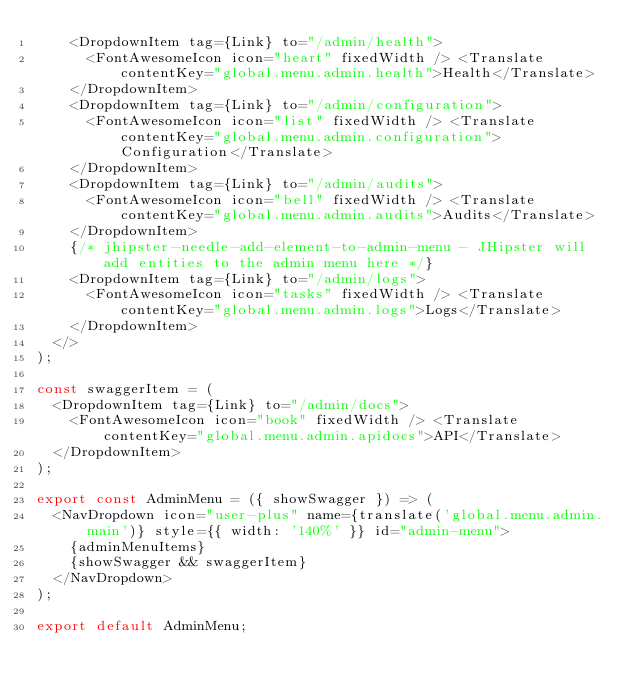Convert code to text. <code><loc_0><loc_0><loc_500><loc_500><_TypeScript_>    <DropdownItem tag={Link} to="/admin/health">
      <FontAwesomeIcon icon="heart" fixedWidth /> <Translate contentKey="global.menu.admin.health">Health</Translate>
    </DropdownItem>
    <DropdownItem tag={Link} to="/admin/configuration">
      <FontAwesomeIcon icon="list" fixedWidth /> <Translate contentKey="global.menu.admin.configuration">Configuration</Translate>
    </DropdownItem>
    <DropdownItem tag={Link} to="/admin/audits">
      <FontAwesomeIcon icon="bell" fixedWidth /> <Translate contentKey="global.menu.admin.audits">Audits</Translate>
    </DropdownItem>
    {/* jhipster-needle-add-element-to-admin-menu - JHipster will add entities to the admin menu here */}
    <DropdownItem tag={Link} to="/admin/logs">
      <FontAwesomeIcon icon="tasks" fixedWidth /> <Translate contentKey="global.menu.admin.logs">Logs</Translate>
    </DropdownItem>
  </>
);

const swaggerItem = (
  <DropdownItem tag={Link} to="/admin/docs">
    <FontAwesomeIcon icon="book" fixedWidth /> <Translate contentKey="global.menu.admin.apidocs">API</Translate>
  </DropdownItem>
);

export const AdminMenu = ({ showSwagger }) => (
  <NavDropdown icon="user-plus" name={translate('global.menu.admin.main')} style={{ width: '140%' }} id="admin-menu">
    {adminMenuItems}
    {showSwagger && swaggerItem}
  </NavDropdown>
);

export default AdminMenu;
</code> 